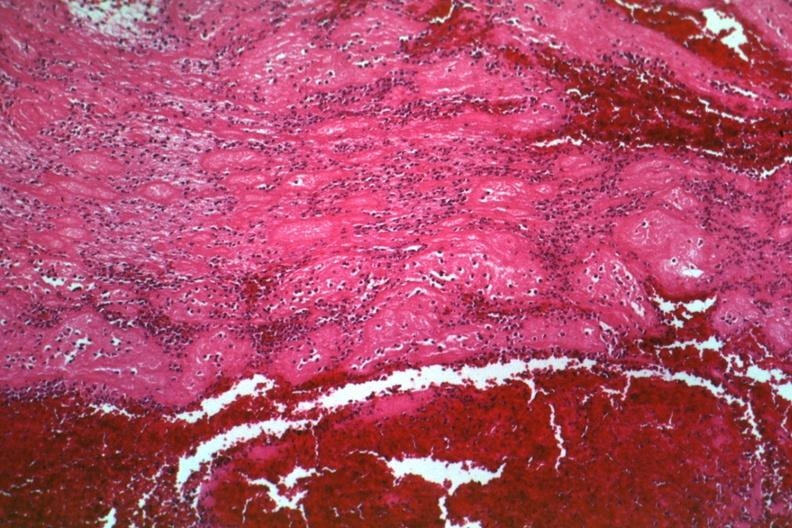does intraductal papillomatosis with apocrine metaplasia show typical structured thrombus quite good?
Answer the question using a single word or phrase. No 